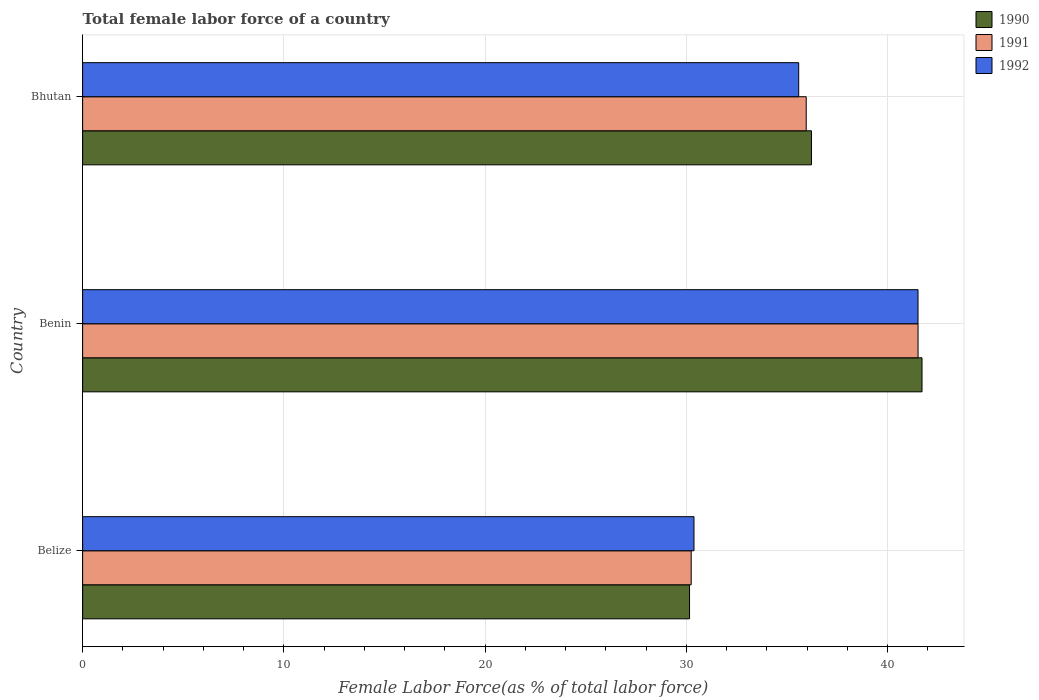How many different coloured bars are there?
Provide a succinct answer. 3. How many bars are there on the 3rd tick from the bottom?
Provide a succinct answer. 3. What is the label of the 3rd group of bars from the top?
Give a very brief answer. Belize. In how many cases, is the number of bars for a given country not equal to the number of legend labels?
Offer a terse response. 0. What is the percentage of female labor force in 1992 in Benin?
Your answer should be very brief. 41.52. Across all countries, what is the maximum percentage of female labor force in 1991?
Provide a succinct answer. 41.52. Across all countries, what is the minimum percentage of female labor force in 1992?
Offer a terse response. 30.38. In which country was the percentage of female labor force in 1990 maximum?
Offer a terse response. Benin. In which country was the percentage of female labor force in 1991 minimum?
Ensure brevity in your answer.  Belize. What is the total percentage of female labor force in 1991 in the graph?
Provide a short and direct response. 107.72. What is the difference between the percentage of female labor force in 1991 in Belize and that in Bhutan?
Provide a short and direct response. -5.72. What is the difference between the percentage of female labor force in 1990 in Belize and the percentage of female labor force in 1992 in Bhutan?
Your answer should be compact. -5.43. What is the average percentage of female labor force in 1992 per country?
Keep it short and to the point. 35.83. What is the difference between the percentage of female labor force in 1990 and percentage of female labor force in 1991 in Belize?
Ensure brevity in your answer.  -0.08. In how many countries, is the percentage of female labor force in 1992 greater than 30 %?
Ensure brevity in your answer.  3. What is the ratio of the percentage of female labor force in 1992 in Benin to that in Bhutan?
Provide a short and direct response. 1.17. Is the percentage of female labor force in 1992 in Belize less than that in Bhutan?
Keep it short and to the point. Yes. Is the difference between the percentage of female labor force in 1990 in Belize and Benin greater than the difference between the percentage of female labor force in 1991 in Belize and Benin?
Your response must be concise. No. What is the difference between the highest and the second highest percentage of female labor force in 1992?
Give a very brief answer. 5.93. What is the difference between the highest and the lowest percentage of female labor force in 1992?
Your answer should be very brief. 11.13. Is the sum of the percentage of female labor force in 1991 in Belize and Bhutan greater than the maximum percentage of female labor force in 1990 across all countries?
Ensure brevity in your answer.  Yes. Is it the case that in every country, the sum of the percentage of female labor force in 1990 and percentage of female labor force in 1992 is greater than the percentage of female labor force in 1991?
Give a very brief answer. Yes. How many bars are there?
Your answer should be very brief. 9. How many countries are there in the graph?
Make the answer very short. 3. Are the values on the major ticks of X-axis written in scientific E-notation?
Your answer should be compact. No. Does the graph contain any zero values?
Your response must be concise. No. Where does the legend appear in the graph?
Your answer should be compact. Top right. How are the legend labels stacked?
Offer a terse response. Vertical. What is the title of the graph?
Make the answer very short. Total female labor force of a country. Does "1981" appear as one of the legend labels in the graph?
Your response must be concise. No. What is the label or title of the X-axis?
Your response must be concise. Female Labor Force(as % of total labor force). What is the label or title of the Y-axis?
Make the answer very short. Country. What is the Female Labor Force(as % of total labor force) of 1990 in Belize?
Provide a short and direct response. 30.16. What is the Female Labor Force(as % of total labor force) in 1991 in Belize?
Provide a succinct answer. 30.24. What is the Female Labor Force(as % of total labor force) in 1992 in Belize?
Offer a terse response. 30.38. What is the Female Labor Force(as % of total labor force) of 1990 in Benin?
Provide a short and direct response. 41.72. What is the Female Labor Force(as % of total labor force) of 1991 in Benin?
Make the answer very short. 41.52. What is the Female Labor Force(as % of total labor force) in 1992 in Benin?
Provide a succinct answer. 41.52. What is the Female Labor Force(as % of total labor force) in 1990 in Bhutan?
Make the answer very short. 36.22. What is the Female Labor Force(as % of total labor force) of 1991 in Bhutan?
Keep it short and to the point. 35.96. What is the Female Labor Force(as % of total labor force) of 1992 in Bhutan?
Ensure brevity in your answer.  35.59. Across all countries, what is the maximum Female Labor Force(as % of total labor force) of 1990?
Offer a very short reply. 41.72. Across all countries, what is the maximum Female Labor Force(as % of total labor force) of 1991?
Provide a short and direct response. 41.52. Across all countries, what is the maximum Female Labor Force(as % of total labor force) in 1992?
Offer a terse response. 41.52. Across all countries, what is the minimum Female Labor Force(as % of total labor force) of 1990?
Ensure brevity in your answer.  30.16. Across all countries, what is the minimum Female Labor Force(as % of total labor force) of 1991?
Offer a very short reply. 30.24. Across all countries, what is the minimum Female Labor Force(as % of total labor force) in 1992?
Give a very brief answer. 30.38. What is the total Female Labor Force(as % of total labor force) of 1990 in the graph?
Your answer should be compact. 108.1. What is the total Female Labor Force(as % of total labor force) in 1991 in the graph?
Provide a short and direct response. 107.72. What is the total Female Labor Force(as % of total labor force) in 1992 in the graph?
Provide a short and direct response. 107.49. What is the difference between the Female Labor Force(as % of total labor force) of 1990 in Belize and that in Benin?
Provide a short and direct response. -11.55. What is the difference between the Female Labor Force(as % of total labor force) of 1991 in Belize and that in Benin?
Keep it short and to the point. -11.27. What is the difference between the Female Labor Force(as % of total labor force) in 1992 in Belize and that in Benin?
Offer a terse response. -11.13. What is the difference between the Female Labor Force(as % of total labor force) in 1990 in Belize and that in Bhutan?
Provide a short and direct response. -6.06. What is the difference between the Female Labor Force(as % of total labor force) in 1991 in Belize and that in Bhutan?
Offer a terse response. -5.72. What is the difference between the Female Labor Force(as % of total labor force) of 1992 in Belize and that in Bhutan?
Your response must be concise. -5.2. What is the difference between the Female Labor Force(as % of total labor force) of 1990 in Benin and that in Bhutan?
Your answer should be compact. 5.49. What is the difference between the Female Labor Force(as % of total labor force) in 1991 in Benin and that in Bhutan?
Give a very brief answer. 5.56. What is the difference between the Female Labor Force(as % of total labor force) in 1992 in Benin and that in Bhutan?
Give a very brief answer. 5.93. What is the difference between the Female Labor Force(as % of total labor force) of 1990 in Belize and the Female Labor Force(as % of total labor force) of 1991 in Benin?
Offer a terse response. -11.36. What is the difference between the Female Labor Force(as % of total labor force) in 1990 in Belize and the Female Labor Force(as % of total labor force) in 1992 in Benin?
Offer a terse response. -11.35. What is the difference between the Female Labor Force(as % of total labor force) of 1991 in Belize and the Female Labor Force(as % of total labor force) of 1992 in Benin?
Your response must be concise. -11.27. What is the difference between the Female Labor Force(as % of total labor force) of 1990 in Belize and the Female Labor Force(as % of total labor force) of 1991 in Bhutan?
Offer a terse response. -5.8. What is the difference between the Female Labor Force(as % of total labor force) in 1990 in Belize and the Female Labor Force(as % of total labor force) in 1992 in Bhutan?
Your response must be concise. -5.42. What is the difference between the Female Labor Force(as % of total labor force) of 1991 in Belize and the Female Labor Force(as % of total labor force) of 1992 in Bhutan?
Offer a terse response. -5.34. What is the difference between the Female Labor Force(as % of total labor force) in 1990 in Benin and the Female Labor Force(as % of total labor force) in 1991 in Bhutan?
Keep it short and to the point. 5.76. What is the difference between the Female Labor Force(as % of total labor force) of 1990 in Benin and the Female Labor Force(as % of total labor force) of 1992 in Bhutan?
Make the answer very short. 6.13. What is the difference between the Female Labor Force(as % of total labor force) in 1991 in Benin and the Female Labor Force(as % of total labor force) in 1992 in Bhutan?
Make the answer very short. 5.93. What is the average Female Labor Force(as % of total labor force) in 1990 per country?
Ensure brevity in your answer.  36.03. What is the average Female Labor Force(as % of total labor force) in 1991 per country?
Make the answer very short. 35.91. What is the average Female Labor Force(as % of total labor force) of 1992 per country?
Make the answer very short. 35.83. What is the difference between the Female Labor Force(as % of total labor force) in 1990 and Female Labor Force(as % of total labor force) in 1991 in Belize?
Ensure brevity in your answer.  -0.08. What is the difference between the Female Labor Force(as % of total labor force) of 1990 and Female Labor Force(as % of total labor force) of 1992 in Belize?
Make the answer very short. -0.22. What is the difference between the Female Labor Force(as % of total labor force) of 1991 and Female Labor Force(as % of total labor force) of 1992 in Belize?
Your answer should be very brief. -0.14. What is the difference between the Female Labor Force(as % of total labor force) of 1990 and Female Labor Force(as % of total labor force) of 1991 in Benin?
Your answer should be compact. 0.2. What is the difference between the Female Labor Force(as % of total labor force) in 1990 and Female Labor Force(as % of total labor force) in 1992 in Benin?
Ensure brevity in your answer.  0.2. What is the difference between the Female Labor Force(as % of total labor force) in 1991 and Female Labor Force(as % of total labor force) in 1992 in Benin?
Provide a short and direct response. 0. What is the difference between the Female Labor Force(as % of total labor force) of 1990 and Female Labor Force(as % of total labor force) of 1991 in Bhutan?
Your answer should be very brief. 0.26. What is the difference between the Female Labor Force(as % of total labor force) in 1990 and Female Labor Force(as % of total labor force) in 1992 in Bhutan?
Ensure brevity in your answer.  0.63. What is the difference between the Female Labor Force(as % of total labor force) in 1991 and Female Labor Force(as % of total labor force) in 1992 in Bhutan?
Offer a very short reply. 0.37. What is the ratio of the Female Labor Force(as % of total labor force) of 1990 in Belize to that in Benin?
Your answer should be compact. 0.72. What is the ratio of the Female Labor Force(as % of total labor force) of 1991 in Belize to that in Benin?
Your answer should be compact. 0.73. What is the ratio of the Female Labor Force(as % of total labor force) of 1992 in Belize to that in Benin?
Provide a short and direct response. 0.73. What is the ratio of the Female Labor Force(as % of total labor force) of 1990 in Belize to that in Bhutan?
Give a very brief answer. 0.83. What is the ratio of the Female Labor Force(as % of total labor force) of 1991 in Belize to that in Bhutan?
Provide a short and direct response. 0.84. What is the ratio of the Female Labor Force(as % of total labor force) of 1992 in Belize to that in Bhutan?
Your answer should be very brief. 0.85. What is the ratio of the Female Labor Force(as % of total labor force) in 1990 in Benin to that in Bhutan?
Your answer should be very brief. 1.15. What is the ratio of the Female Labor Force(as % of total labor force) in 1991 in Benin to that in Bhutan?
Offer a terse response. 1.15. What is the ratio of the Female Labor Force(as % of total labor force) in 1992 in Benin to that in Bhutan?
Your answer should be very brief. 1.17. What is the difference between the highest and the second highest Female Labor Force(as % of total labor force) of 1990?
Provide a short and direct response. 5.49. What is the difference between the highest and the second highest Female Labor Force(as % of total labor force) of 1991?
Provide a succinct answer. 5.56. What is the difference between the highest and the second highest Female Labor Force(as % of total labor force) of 1992?
Provide a short and direct response. 5.93. What is the difference between the highest and the lowest Female Labor Force(as % of total labor force) of 1990?
Provide a succinct answer. 11.55. What is the difference between the highest and the lowest Female Labor Force(as % of total labor force) of 1991?
Your answer should be very brief. 11.27. What is the difference between the highest and the lowest Female Labor Force(as % of total labor force) in 1992?
Give a very brief answer. 11.13. 